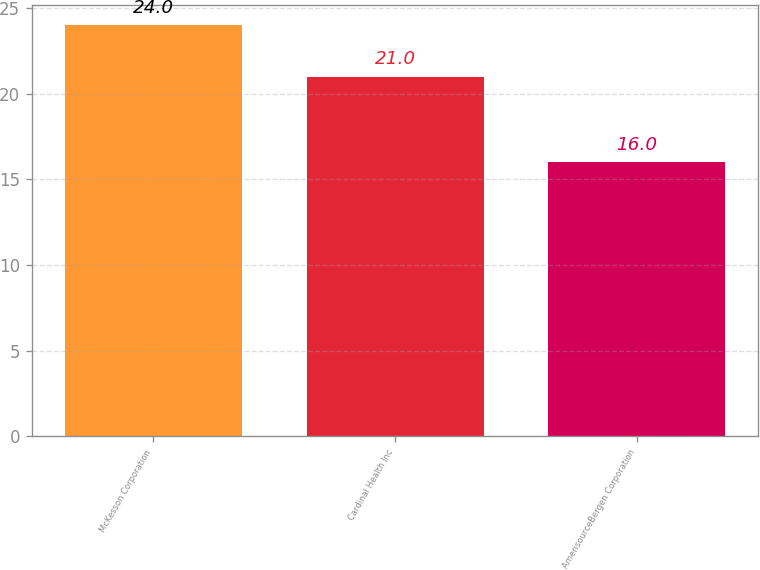<chart> <loc_0><loc_0><loc_500><loc_500><bar_chart><fcel>McKesson Corporation<fcel>Cardinal Health Inc<fcel>AmerisourceBergen Corporation<nl><fcel>24<fcel>21<fcel>16<nl></chart> 